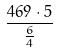<formula> <loc_0><loc_0><loc_500><loc_500>\frac { 4 6 9 \cdot 5 } { \frac { 6 } { 4 } }</formula> 